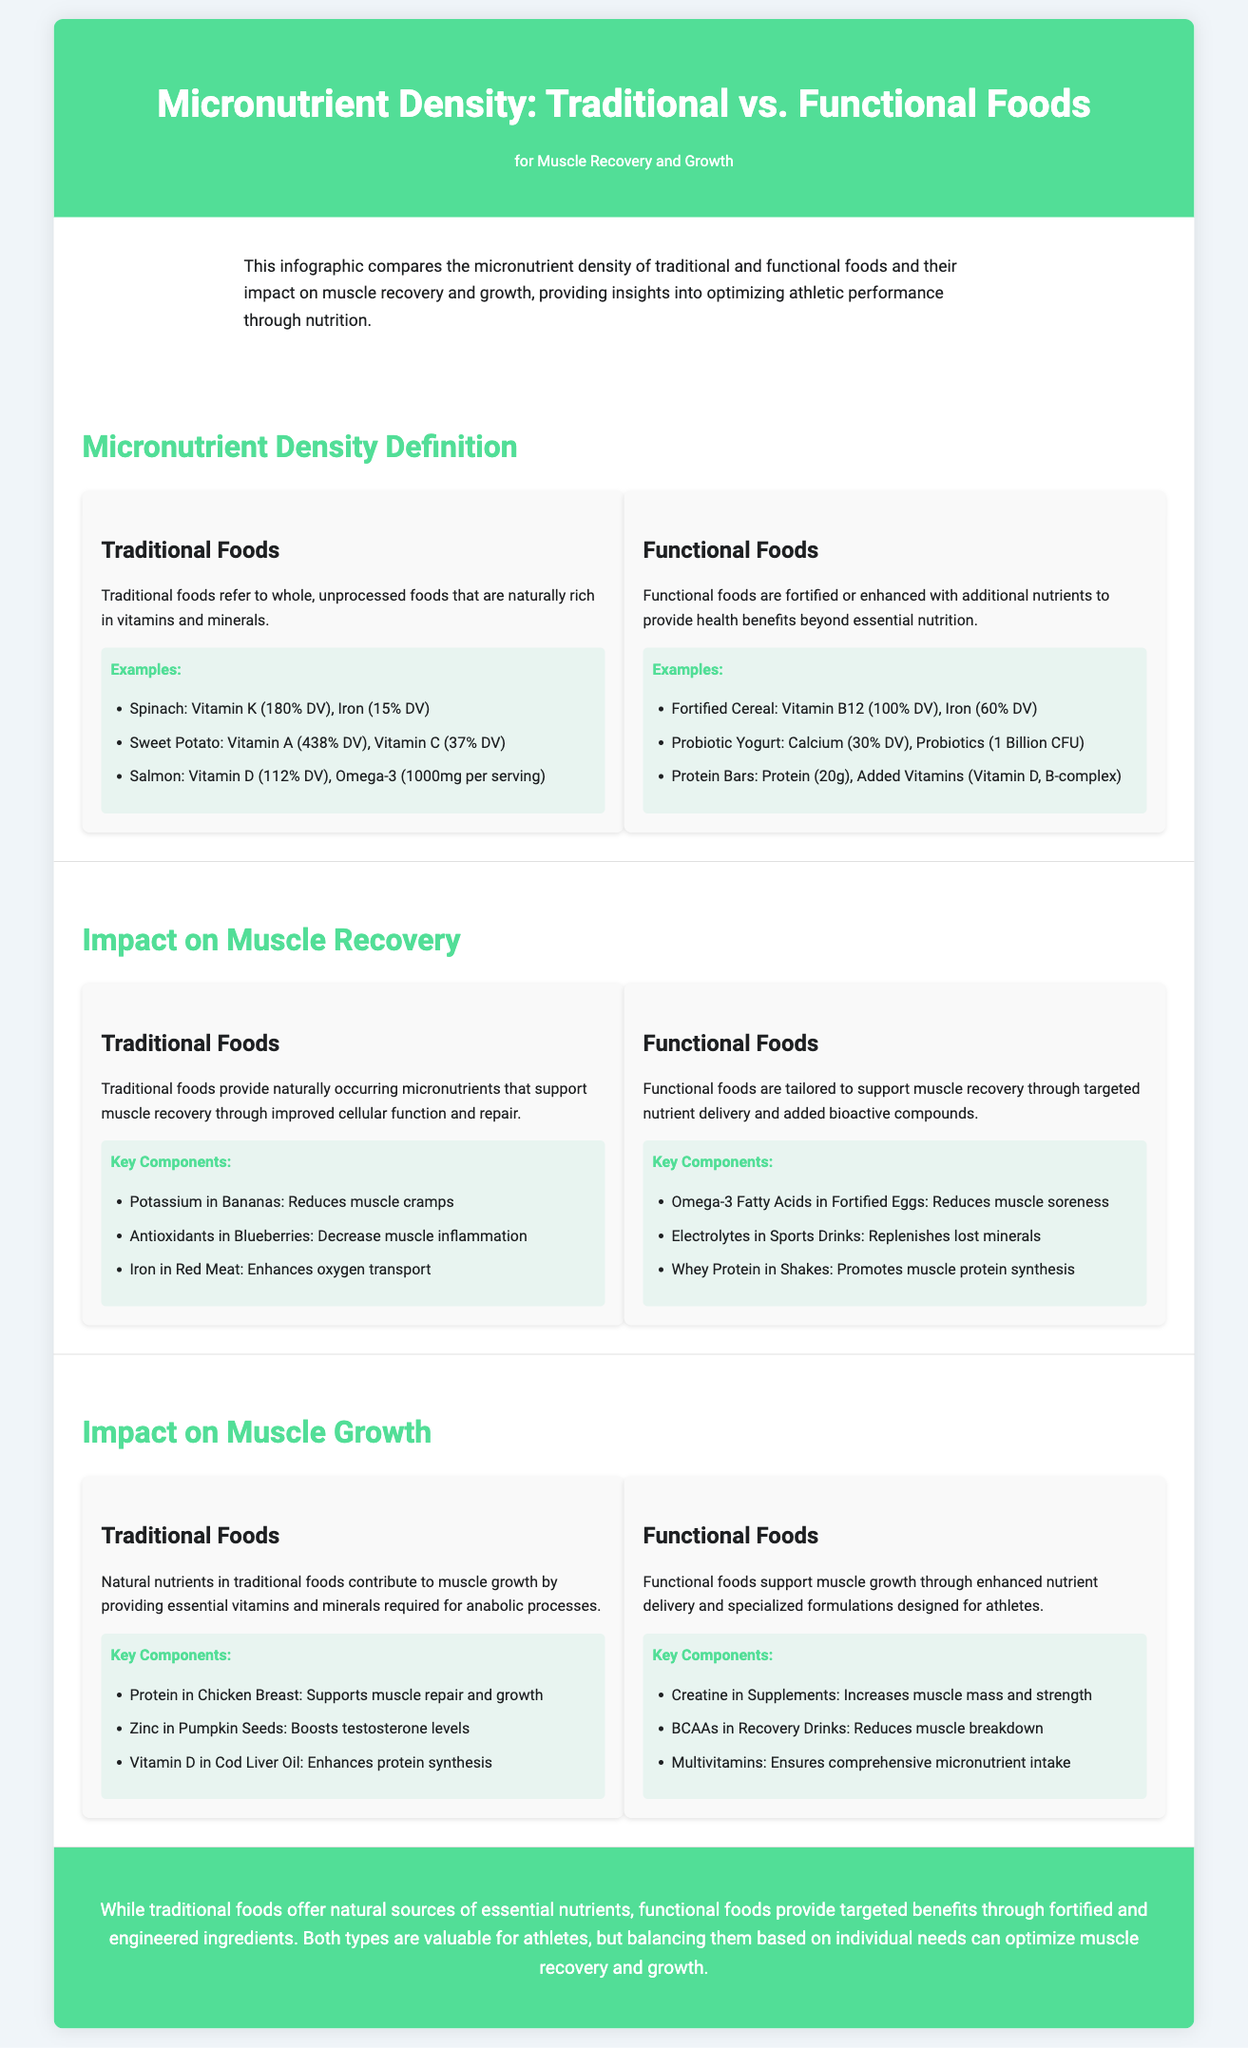what are traditional foods? Traditional foods refer to whole, unprocessed foods that are naturally rich in vitamins and minerals.
Answer: whole, unprocessed foods what are functional foods? Functional foods are fortified or enhanced with additional nutrients to provide health benefits beyond essential nutrition.
Answer: fortified or enhanced foods what is an example of a traditional food and its micronutrient value? Spinach is a traditional food with Vitamin K (180% DV) and Iron (15% DV).
Answer: Spinach: Vitamin K (180% DV), Iron (15% DV) which micronutrient in bananas helps reduce muscle cramps? Potassium in Bananas helps reduce muscle cramps.
Answer: Potassium what component in whey protein shakes promotes muscle protein synthesis? Whey Protein in Shakes promotes muscle protein synthesis.
Answer: Whey Protein how does zinc in pumpkin seeds impact muscle growth? Zinc in Pumpkin Seeds boosts testosterone levels, aiding muscle growth.
Answer: boosts testosterone levels which component in fortified eggs helps reduce muscle soreness? Omega-3 Fatty Acids in Fortified Eggs help reduce muscle soreness.
Answer: Omega-3 Fatty Acids what is the primary benefit of functional foods compared to traditional foods? Functional foods provide targeted benefits through fortified and engineered ingredients.
Answer: targeted benefits what is a key component of protein bars found in functional foods? Protein (20g) is a key component of protein bars.
Answer: Protein (20g) 